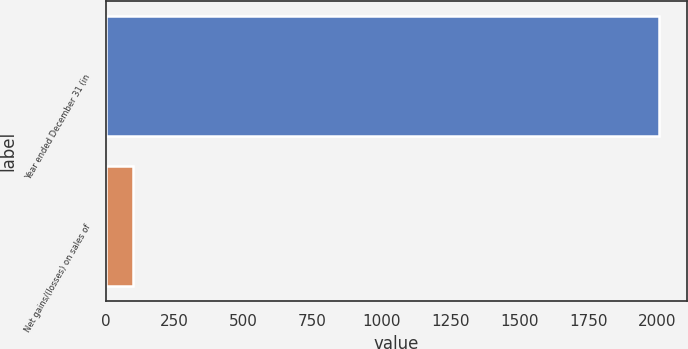Convert chart. <chart><loc_0><loc_0><loc_500><loc_500><bar_chart><fcel>Year ended December 31 (in<fcel>Net gains/(losses) on sales of<nl><fcel>2007<fcel>99<nl></chart> 